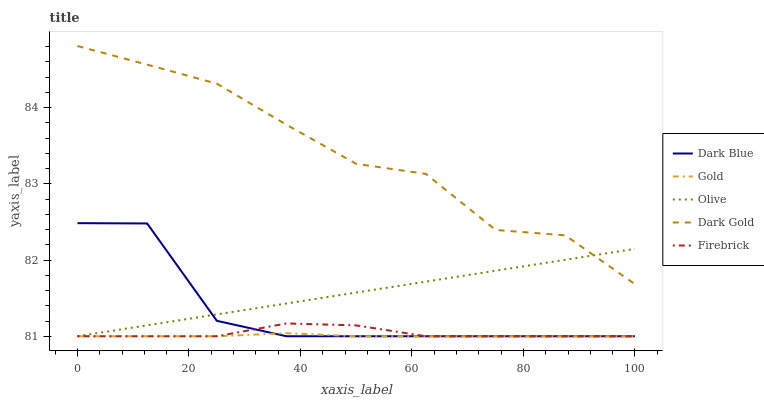Does Dark Blue have the minimum area under the curve?
Answer yes or no. No. Does Dark Blue have the maximum area under the curve?
Answer yes or no. No. Is Firebrick the smoothest?
Answer yes or no. No. Is Firebrick the roughest?
Answer yes or no. No. Does Dark Gold have the lowest value?
Answer yes or no. No. Does Dark Blue have the highest value?
Answer yes or no. No. Is Gold less than Dark Gold?
Answer yes or no. Yes. Is Dark Gold greater than Gold?
Answer yes or no. Yes. Does Gold intersect Dark Gold?
Answer yes or no. No. 